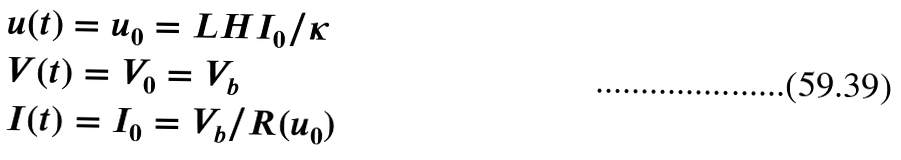<formula> <loc_0><loc_0><loc_500><loc_500>& u ( t ) = u _ { 0 } = L H I _ { 0 } / \kappa \\ & V ( t ) = V _ { 0 } = V _ { b } \\ & I ( t ) = I _ { 0 } = V _ { b } / R ( u _ { 0 } )</formula> 